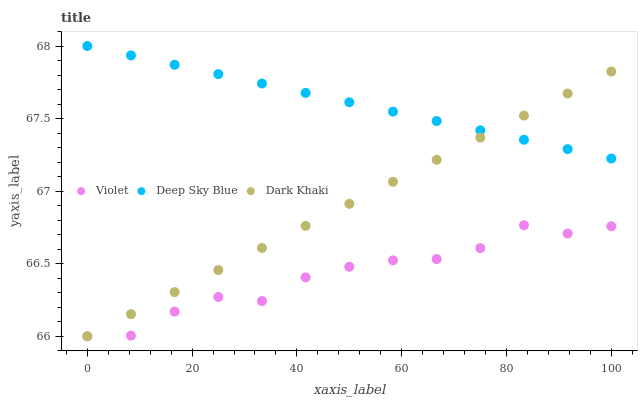Does Violet have the minimum area under the curve?
Answer yes or no. Yes. Does Deep Sky Blue have the maximum area under the curve?
Answer yes or no. Yes. Does Deep Sky Blue have the minimum area under the curve?
Answer yes or no. No. Does Violet have the maximum area under the curve?
Answer yes or no. No. Is Deep Sky Blue the smoothest?
Answer yes or no. Yes. Is Violet the roughest?
Answer yes or no. Yes. Is Violet the smoothest?
Answer yes or no. No. Is Deep Sky Blue the roughest?
Answer yes or no. No. Does Dark Khaki have the lowest value?
Answer yes or no. Yes. Does Deep Sky Blue have the lowest value?
Answer yes or no. No. Does Deep Sky Blue have the highest value?
Answer yes or no. Yes. Does Violet have the highest value?
Answer yes or no. No. Is Violet less than Deep Sky Blue?
Answer yes or no. Yes. Is Deep Sky Blue greater than Violet?
Answer yes or no. Yes. Does Dark Khaki intersect Deep Sky Blue?
Answer yes or no. Yes. Is Dark Khaki less than Deep Sky Blue?
Answer yes or no. No. Is Dark Khaki greater than Deep Sky Blue?
Answer yes or no. No. Does Violet intersect Deep Sky Blue?
Answer yes or no. No. 